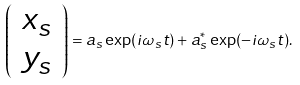<formula> <loc_0><loc_0><loc_500><loc_500>\left ( \begin{array} { c } x _ { s } \\ y _ { s } \end{array} \right ) = a _ { s } \exp ( i \omega _ { s } t ) + a _ { s } ^ { \ast } \exp ( - i \omega _ { s } t ) .</formula> 